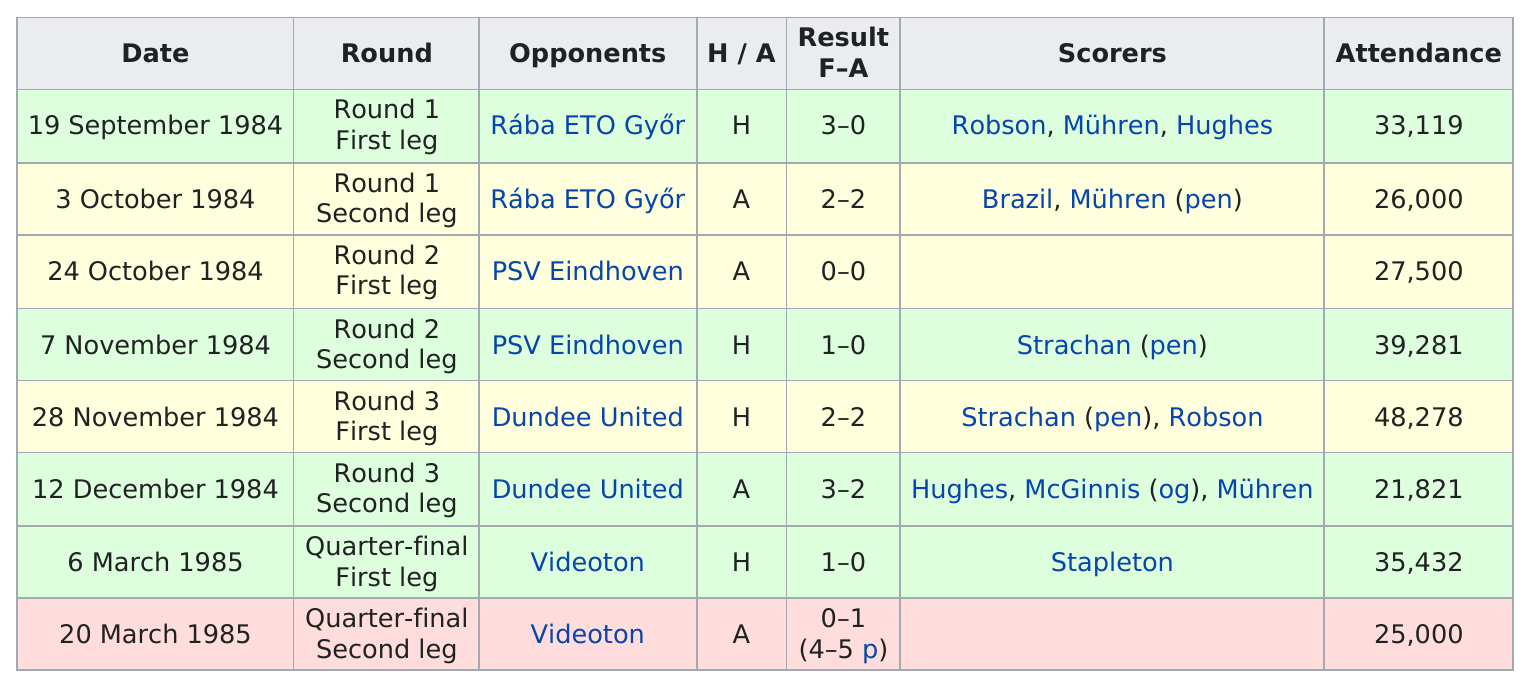Draw attention to some important aspects in this diagram. On or prior to October 24, please name a game that ended in a tie. The most recent such game took place on November 28, 1984. The average number of fans in attendance in the first three games was 28,873. Stapleton is the only person to have scored in the March 6 game against Videoton this season. The total attendance for the UEFA Cup dates of September 19th and November 7th, 1984, is 72,400. What game had the most fans in attendance on 28 November 1984? 